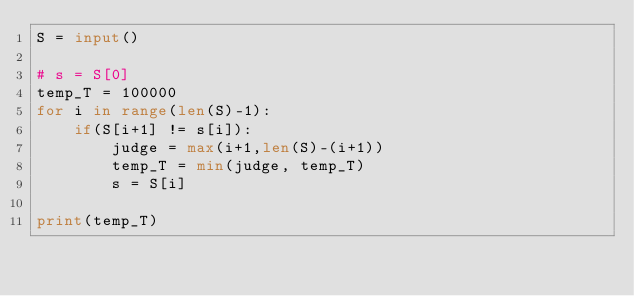Convert code to text. <code><loc_0><loc_0><loc_500><loc_500><_Python_>S = input()

# s = S[0]
temp_T = 100000
for i in range(len(S)-1):
    if(S[i+1] != s[i]):
        judge = max(i+1,len(S)-(i+1))
        temp_T = min(judge, temp_T)
        s = S[i]

print(temp_T)
</code> 